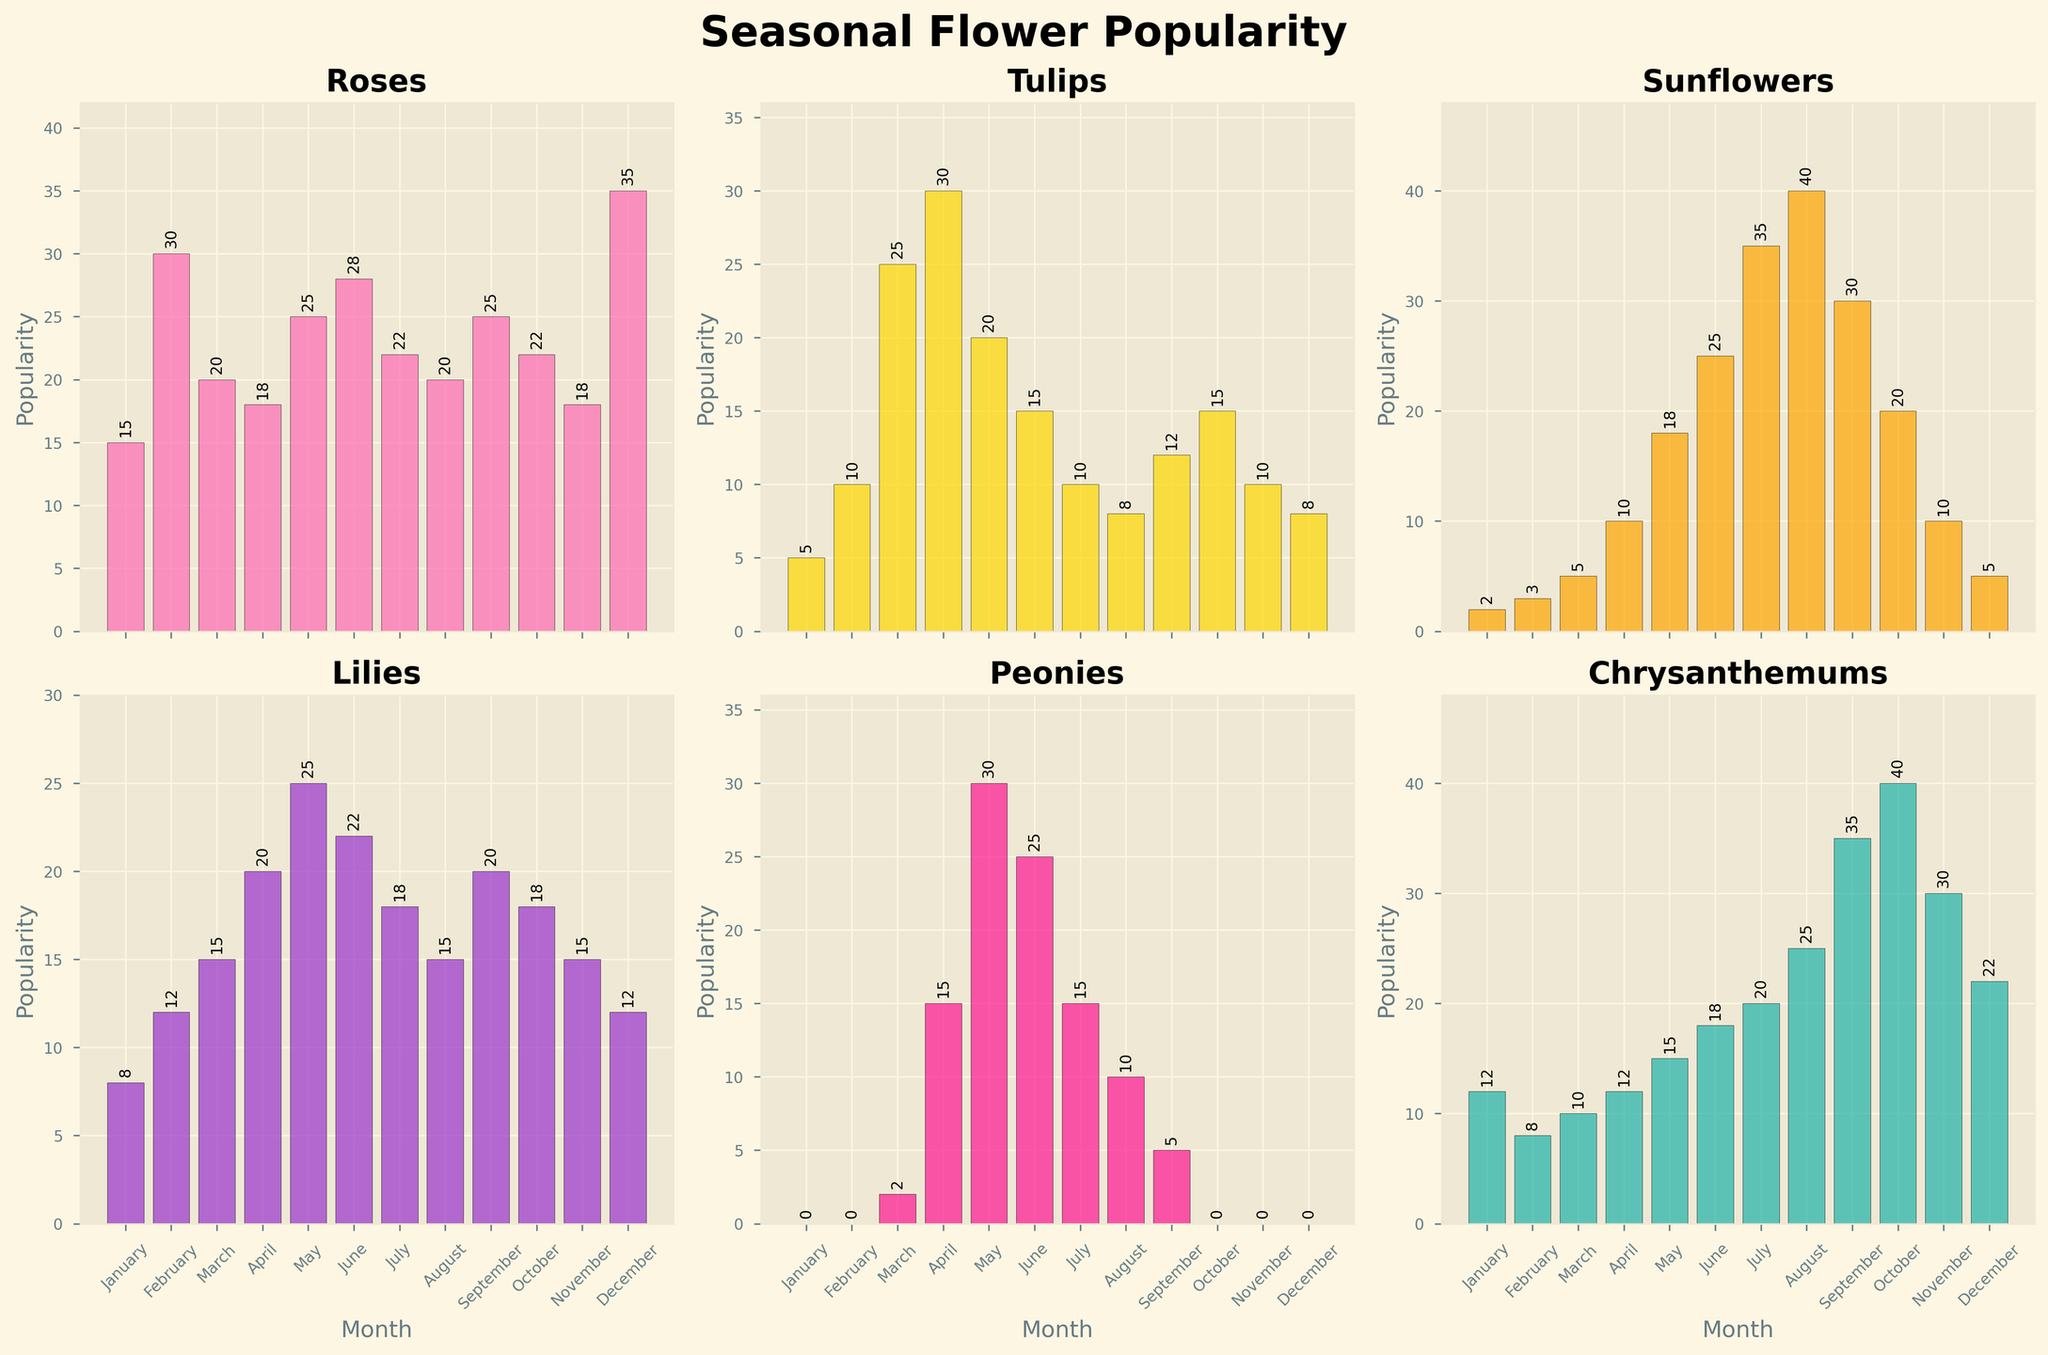Which month has the highest popularity for Roses? In the subplots, look for the bar representing the highest value in the graph labeled "Roses". The bar in the month of December reaches the highest point.
Answer: December What is the average popularity of Tulips from January to June? Add the number of Tulips sold from January to June (5 + 10 + 25 + 30 + 20 + 15), which equals 105, and divide this by 6, resulting in 17.5.
Answer: 17.5 Which flower had the lowest popularity in January? Look at the bars for each flower in January; Peonies have a height of 0, indicating they had the lowest popularity.
Answer: Peonies How does the popularity of Sunflowers in August compare to that in July? Check the heights of the bars for "Sunflowers" in July and August. In August, the height is 40, and in July, it is 35, so it's higher in August.
Answer: Higher in August What is the total popularity of all flowers in May? Sum the popularity values for all flowers in May (25 + 20 + 18 + 25 + 30 + 15) to get 133.
Answer: 133 How does the popularity trend of Lilies change over the year? Examine the bar heights for Lilies from January to December. The values increase from January to May, decrease slightly until August, increase again in September, and then fluctuate slightly through the end of the year.
Answer: Fluctuating with peaks in May and September Which flower has the most consistent popularity across all months? Look for the flower with bars of relatively similar height in all months. Chrysanthemums show a more consistent popularity trend.
Answer: Chrysanthemums In which month are Peonies the most popular? Identify the month with the highest bar in the "Peonies" subplot. The highest bar appears in May.
Answer: May 